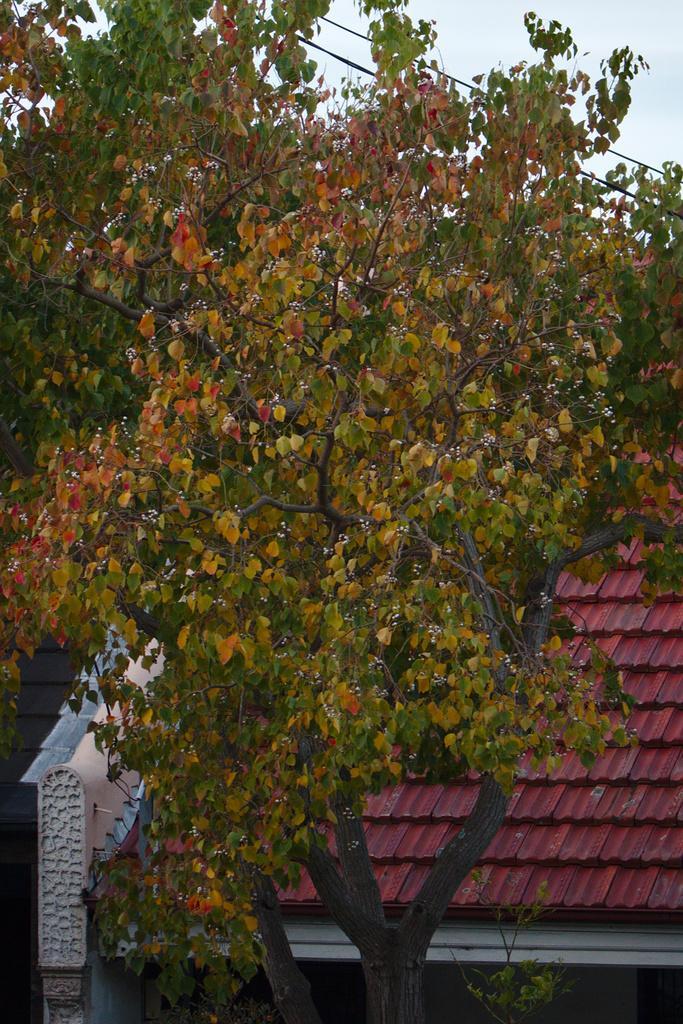In one or two sentences, can you explain what this image depicts? In this image we can see there is a roof and a tree. In the background we can see the sky. 